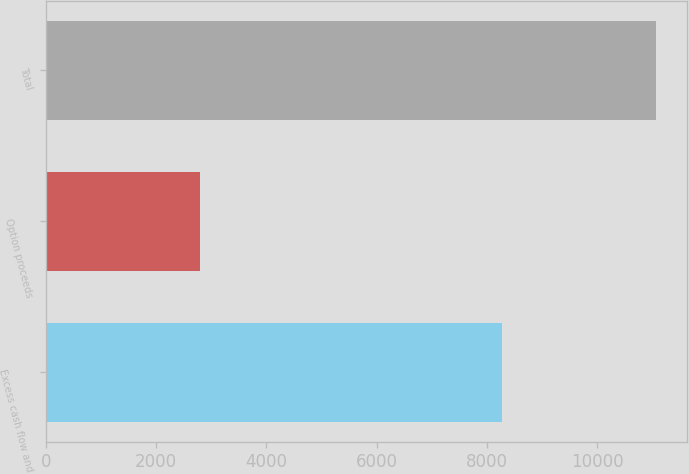<chart> <loc_0><loc_0><loc_500><loc_500><bar_chart><fcel>Excess cash flow and<fcel>Option proceeds<fcel>Total<nl><fcel>8280<fcel>2789<fcel>11069<nl></chart> 